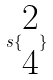<formula> <loc_0><loc_0><loc_500><loc_500>s \{ \begin{matrix} 2 \\ 4 \end{matrix} \}</formula> 